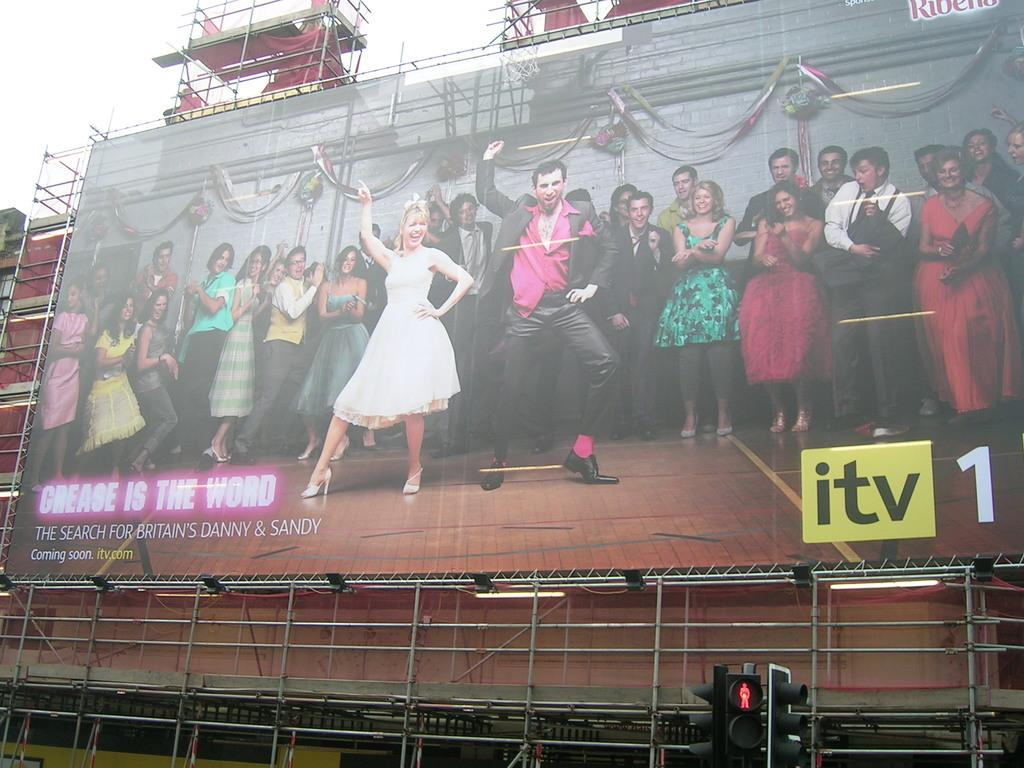<image>
Share a concise interpretation of the image provided. Grease is the Word is coming soon on itv.com. 